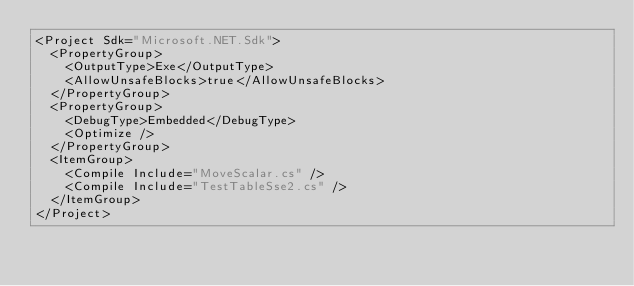<code> <loc_0><loc_0><loc_500><loc_500><_XML_><Project Sdk="Microsoft.NET.Sdk">
  <PropertyGroup>
    <OutputType>Exe</OutputType>
    <AllowUnsafeBlocks>true</AllowUnsafeBlocks>
  </PropertyGroup>
  <PropertyGroup>
    <DebugType>Embedded</DebugType>
    <Optimize />
  </PropertyGroup>
  <ItemGroup>
    <Compile Include="MoveScalar.cs" />
    <Compile Include="TestTableSse2.cs" />
  </ItemGroup>
</Project>
</code> 